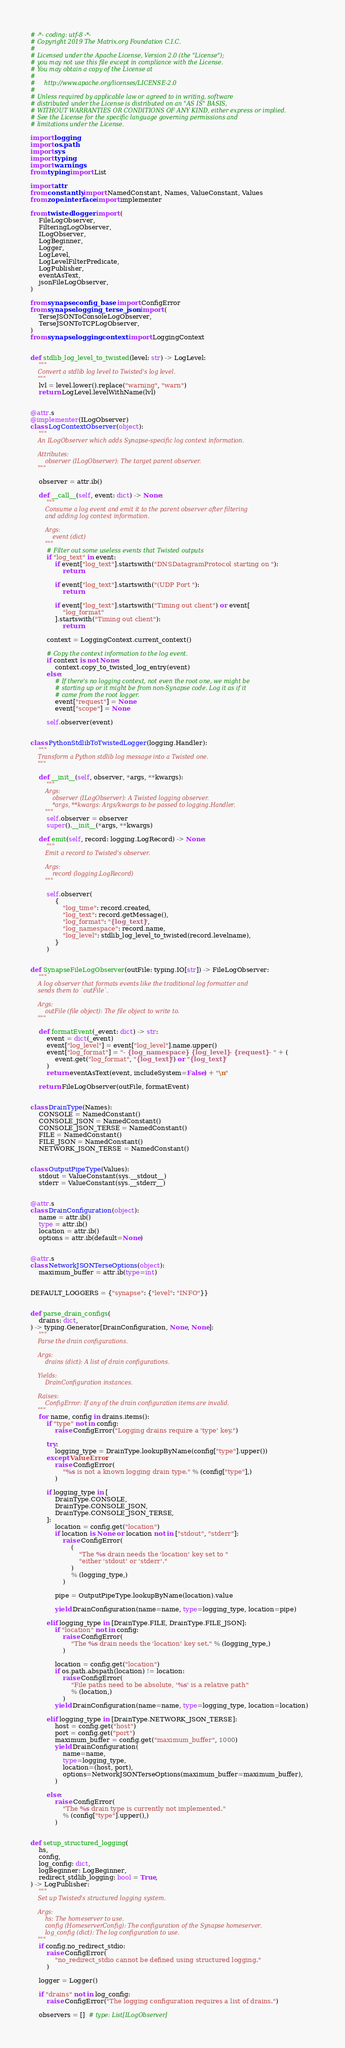Convert code to text. <code><loc_0><loc_0><loc_500><loc_500><_Python_># -*- coding: utf-8 -*-
# Copyright 2019 The Matrix.org Foundation C.I.C.
#
# Licensed under the Apache License, Version 2.0 (the "License");
# you may not use this file except in compliance with the License.
# You may obtain a copy of the License at
#
#     http://www.apache.org/licenses/LICENSE-2.0
#
# Unless required by applicable law or agreed to in writing, software
# distributed under the License is distributed on an "AS IS" BASIS,
# WITHOUT WARRANTIES OR CONDITIONS OF ANY KIND, either express or implied.
# See the License for the specific language governing permissions and
# limitations under the License.

import logging
import os.path
import sys
import typing
import warnings
from typing import List

import attr
from constantly import NamedConstant, Names, ValueConstant, Values
from zope.interface import implementer

from twisted.logger import (
    FileLogObserver,
    FilteringLogObserver,
    ILogObserver,
    LogBeginner,
    Logger,
    LogLevel,
    LogLevelFilterPredicate,
    LogPublisher,
    eventAsText,
    jsonFileLogObserver,
)

from synapse.config._base import ConfigError
from synapse.logging._terse_json import (
    TerseJSONToConsoleLogObserver,
    TerseJSONToTCPLogObserver,
)
from synapse.logging.context import LoggingContext


def stdlib_log_level_to_twisted(level: str) -> LogLevel:
    """
    Convert a stdlib log level to Twisted's log level.
    """
    lvl = level.lower().replace("warning", "warn")
    return LogLevel.levelWithName(lvl)


@attr.s
@implementer(ILogObserver)
class LogContextObserver(object):
    """
    An ILogObserver which adds Synapse-specific log context information.

    Attributes:
        observer (ILogObserver): The target parent observer.
    """

    observer = attr.ib()

    def __call__(self, event: dict) -> None:
        """
        Consume a log event and emit it to the parent observer after filtering
        and adding log context information.

        Args:
            event (dict)
        """
        # Filter out some useless events that Twisted outputs
        if "log_text" in event:
            if event["log_text"].startswith("DNSDatagramProtocol starting on "):
                return

            if event["log_text"].startswith("(UDP Port "):
                return

            if event["log_text"].startswith("Timing out client") or event[
                "log_format"
            ].startswith("Timing out client"):
                return

        context = LoggingContext.current_context()

        # Copy the context information to the log event.
        if context is not None:
            context.copy_to_twisted_log_entry(event)
        else:
            # If there's no logging context, not even the root one, we might be
            # starting up or it might be from non-Synapse code. Log it as if it
            # came from the root logger.
            event["request"] = None
            event["scope"] = None

        self.observer(event)


class PythonStdlibToTwistedLogger(logging.Handler):
    """
    Transform a Python stdlib log message into a Twisted one.
    """

    def __init__(self, observer, *args, **kwargs):
        """
        Args:
            observer (ILogObserver): A Twisted logging observer.
            *args, **kwargs: Args/kwargs to be passed to logging.Handler.
        """
        self.observer = observer
        super().__init__(*args, **kwargs)

    def emit(self, record: logging.LogRecord) -> None:
        """
        Emit a record to Twisted's observer.

        Args:
            record (logging.LogRecord)
        """

        self.observer(
            {
                "log_time": record.created,
                "log_text": record.getMessage(),
                "log_format": "{log_text}",
                "log_namespace": record.name,
                "log_level": stdlib_log_level_to_twisted(record.levelname),
            }
        )


def SynapseFileLogObserver(outFile: typing.IO[str]) -> FileLogObserver:
    """
    A log observer that formats events like the traditional log formatter and
    sends them to `outFile`.

    Args:
        outFile (file object): The file object to write to.
    """

    def formatEvent(_event: dict) -> str:
        event = dict(_event)
        event["log_level"] = event["log_level"].name.upper()
        event["log_format"] = "- {log_namespace} - {log_level} - {request} - " + (
            event.get("log_format", "{log_text}") or "{log_text}"
        )
        return eventAsText(event, includeSystem=False) + "\n"

    return FileLogObserver(outFile, formatEvent)


class DrainType(Names):
    CONSOLE = NamedConstant()
    CONSOLE_JSON = NamedConstant()
    CONSOLE_JSON_TERSE = NamedConstant()
    FILE = NamedConstant()
    FILE_JSON = NamedConstant()
    NETWORK_JSON_TERSE = NamedConstant()


class OutputPipeType(Values):
    stdout = ValueConstant(sys.__stdout__)
    stderr = ValueConstant(sys.__stderr__)


@attr.s
class DrainConfiguration(object):
    name = attr.ib()
    type = attr.ib()
    location = attr.ib()
    options = attr.ib(default=None)


@attr.s
class NetworkJSONTerseOptions(object):
    maximum_buffer = attr.ib(type=int)


DEFAULT_LOGGERS = {"synapse": {"level": "INFO"}}


def parse_drain_configs(
    drains: dict,
) -> typing.Generator[DrainConfiguration, None, None]:
    """
    Parse the drain configurations.

    Args:
        drains (dict): A list of drain configurations.

    Yields:
        DrainConfiguration instances.

    Raises:
        ConfigError: If any of the drain configuration items are invalid.
    """
    for name, config in drains.items():
        if "type" not in config:
            raise ConfigError("Logging drains require a 'type' key.")

        try:
            logging_type = DrainType.lookupByName(config["type"].upper())
        except ValueError:
            raise ConfigError(
                "%s is not a known logging drain type." % (config["type"],)
            )

        if logging_type in [
            DrainType.CONSOLE,
            DrainType.CONSOLE_JSON,
            DrainType.CONSOLE_JSON_TERSE,
        ]:
            location = config.get("location")
            if location is None or location not in ["stdout", "stderr"]:
                raise ConfigError(
                    (
                        "The %s drain needs the 'location' key set to "
                        "either 'stdout' or 'stderr'."
                    )
                    % (logging_type,)
                )

            pipe = OutputPipeType.lookupByName(location).value

            yield DrainConfiguration(name=name, type=logging_type, location=pipe)

        elif logging_type in [DrainType.FILE, DrainType.FILE_JSON]:
            if "location" not in config:
                raise ConfigError(
                    "The %s drain needs the 'location' key set." % (logging_type,)
                )

            location = config.get("location")
            if os.path.abspath(location) != location:
                raise ConfigError(
                    "File paths need to be absolute, '%s' is a relative path"
                    % (location,)
                )
            yield DrainConfiguration(name=name, type=logging_type, location=location)

        elif logging_type in [DrainType.NETWORK_JSON_TERSE]:
            host = config.get("host")
            port = config.get("port")
            maximum_buffer = config.get("maximum_buffer", 1000)
            yield DrainConfiguration(
                name=name,
                type=logging_type,
                location=(host, port),
                options=NetworkJSONTerseOptions(maximum_buffer=maximum_buffer),
            )

        else:
            raise ConfigError(
                "The %s drain type is currently not implemented."
                % (config["type"].upper(),)
            )


def setup_structured_logging(
    hs,
    config,
    log_config: dict,
    logBeginner: LogBeginner,
    redirect_stdlib_logging: bool = True,
) -> LogPublisher:
    """
    Set up Twisted's structured logging system.

    Args:
        hs: The homeserver to use.
        config (HomeserverConfig): The configuration of the Synapse homeserver.
        log_config (dict): The log configuration to use.
    """
    if config.no_redirect_stdio:
        raise ConfigError(
            "no_redirect_stdio cannot be defined using structured logging."
        )

    logger = Logger()

    if "drains" not in log_config:
        raise ConfigError("The logging configuration requires a list of drains.")

    observers = []  # type: List[ILogObserver]
</code> 